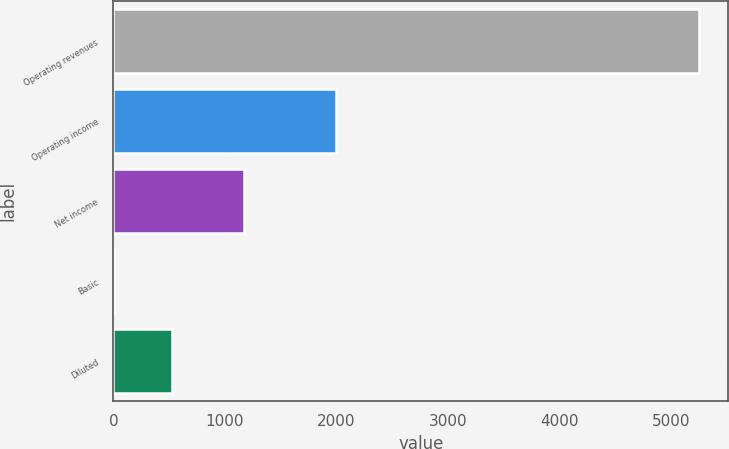Convert chart. <chart><loc_0><loc_0><loc_500><loc_500><bar_chart><fcel>Operating revenues<fcel>Operating income<fcel>Net income<fcel>Basic<fcel>Diluted<nl><fcel>5250<fcel>1998<fcel>1168<fcel>1.45<fcel>526.31<nl></chart> 